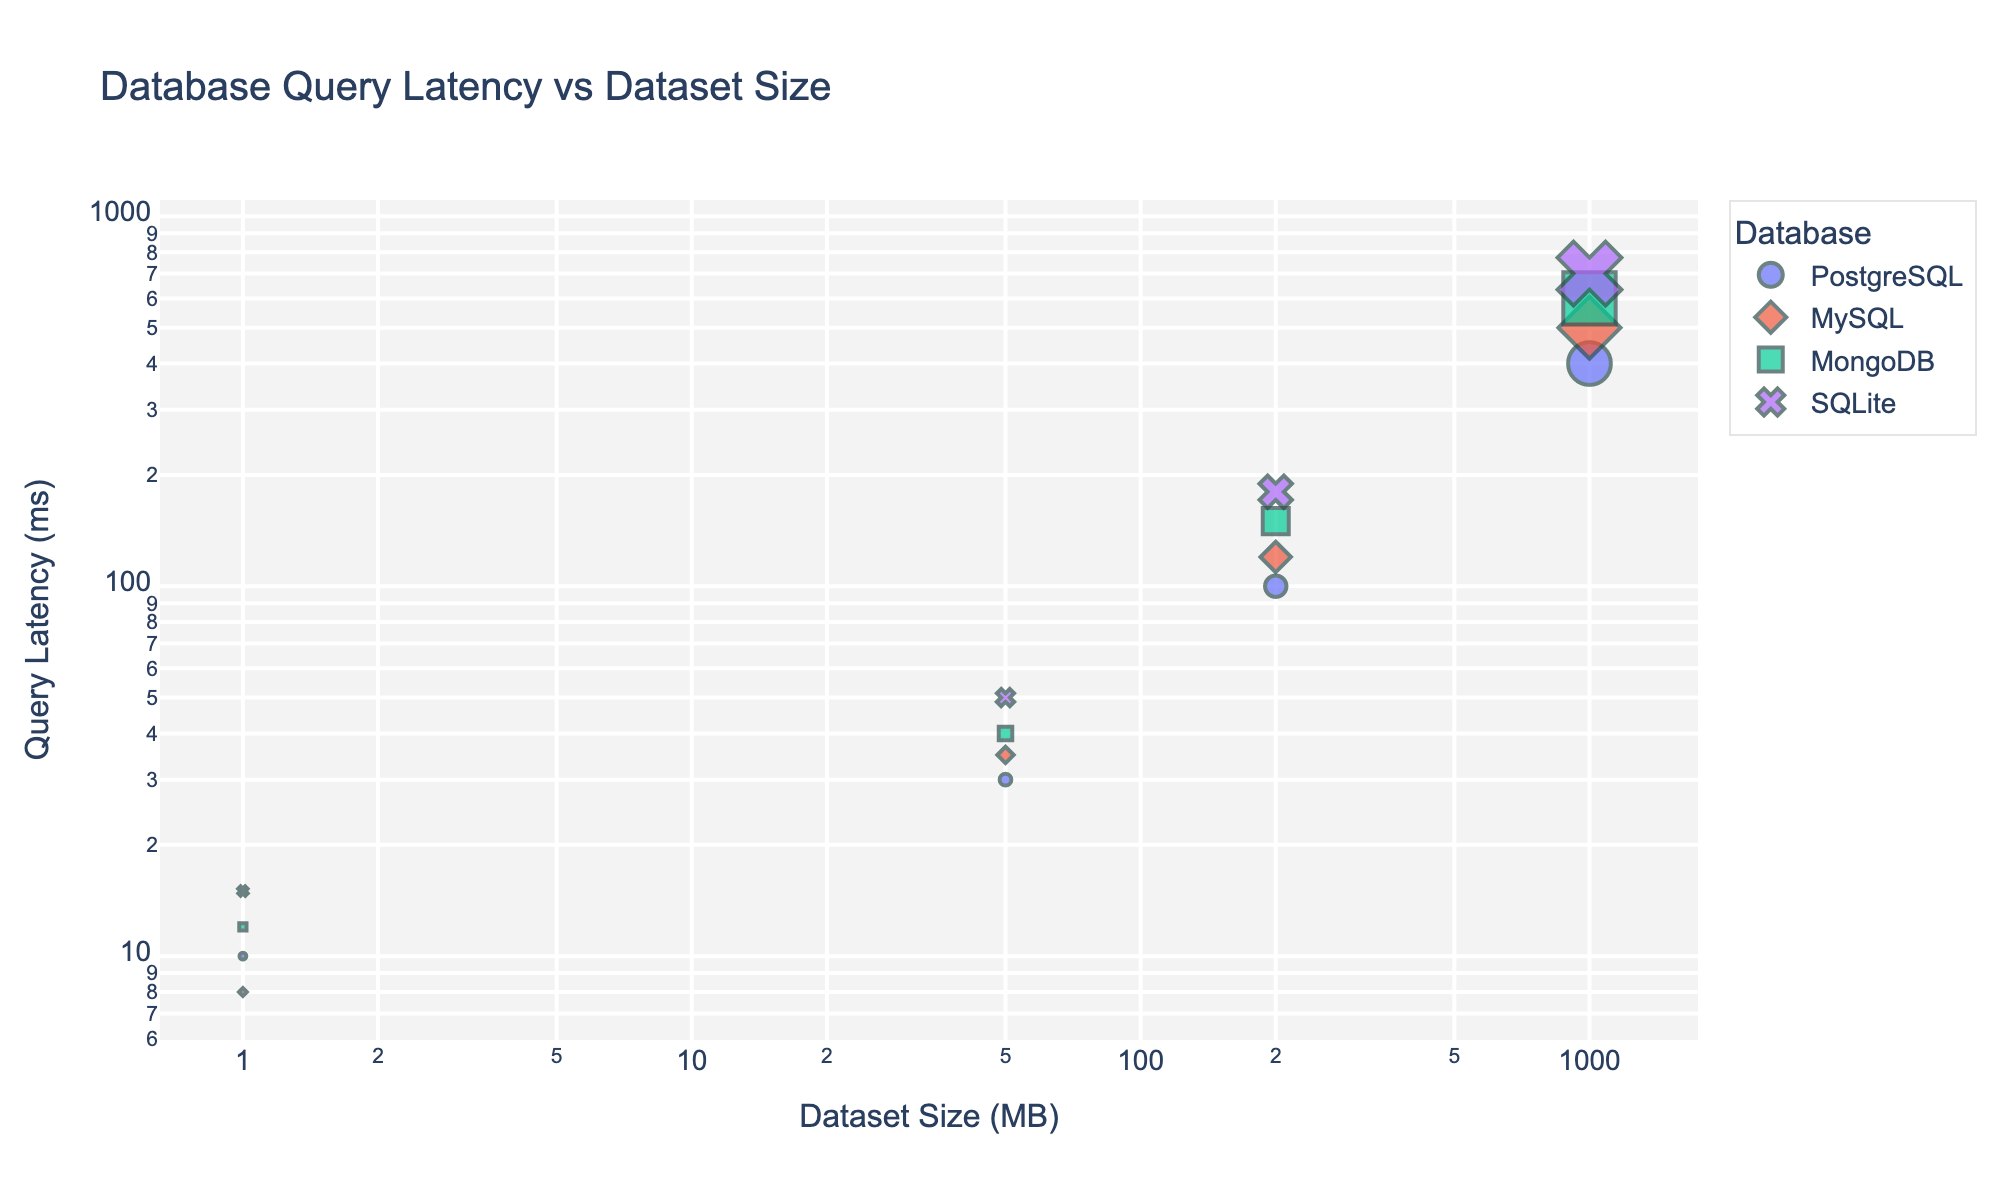How many database management systems are compared in this plot? The plot has different markers for each database management system, identified by the color and symbol. By counting these unique markers in the legend, we can determine the number of database management systems.
Answer: 4 What is the query latency for MySQL with a dataset size of 200 MB? We locate the set of points associated with MySQL. Then, we find the point where the dataset size is 200 MB on the x-axis and note the corresponding y-axis value for query latency.
Answer: 120 ms Which database management system has the highest query latency for a 1000 MB dataset? Identify the points corresponding to 1000 MB in dataset size for each database management system. Then, compare their y-axis values to find the one with the highest query latency.
Answer: SQLite Which system outperforms others for small datasets queries in terms of latency? For small datasets (1 MB), compare the y-axis values (query latencies) of each database system. The system with the lowest y-axis value has the best performance.
Answer: MySQL How does the query latency of PostgreSQL change as the dataset size increases from 1 MB to 1000 MB? Track the progression of latency values for PostgreSQL from 1 MB to 1000 MB on the chart. Note the latency values at 1 MB, 50 MB, 200 MB, and 1000 MB and describe the overall trend.
Answer: Increases from 10 ms to 400 ms Which database management system has the lowest latency for medium-sized datasets (50 MB)? Find all the data points corresponding to 50 MB dataset size and compare their y-axis values. Identify the system associated with the lowest value.
Answer: PostgreSQL What's the relative query latency difference between PostgreSQL and MongoDB for a dataset size of 200 MB? Locate the points for PostgreSQL and MongoDB corresponding to 200 MB dataset size. Calculate the difference in their y-axis values. MongoDB's latency - PostgreSQL's latency.
Answer: 50 ms Do all systems display a logarithmic increase in query latency as the dataset size increases? Evaluate the trend for each system by observing the change in query latency values across different dataset sizes in logarithmic scale on both axes. Determine if each trend forms a straight line which indicates a logarithmic relationship.
Answer: Yes What is the average query latency for 1000 MB datasets across all systems? Identify the latency values at 1000 MB for all systems and calculate the average: (400 + 500 + 600 + 700) / 4.
Answer: 550 ms 